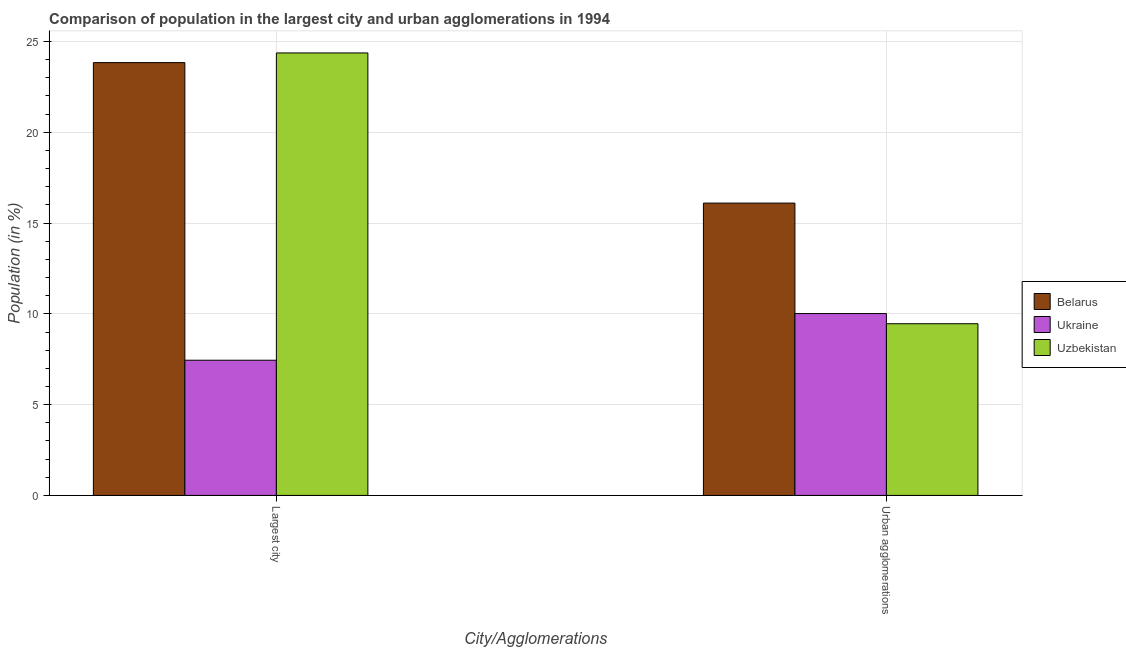How many different coloured bars are there?
Offer a very short reply. 3. Are the number of bars on each tick of the X-axis equal?
Your response must be concise. Yes. How many bars are there on the 2nd tick from the left?
Offer a terse response. 3. How many bars are there on the 1st tick from the right?
Your answer should be very brief. 3. What is the label of the 2nd group of bars from the left?
Make the answer very short. Urban agglomerations. What is the population in the largest city in Belarus?
Keep it short and to the point. 23.84. Across all countries, what is the maximum population in urban agglomerations?
Ensure brevity in your answer.  16.1. Across all countries, what is the minimum population in urban agglomerations?
Provide a short and direct response. 9.46. In which country was the population in the largest city maximum?
Ensure brevity in your answer.  Uzbekistan. In which country was the population in the largest city minimum?
Your answer should be very brief. Ukraine. What is the total population in the largest city in the graph?
Your answer should be compact. 55.65. What is the difference between the population in urban agglomerations in Ukraine and that in Uzbekistan?
Your answer should be very brief. 0.56. What is the difference between the population in the largest city in Belarus and the population in urban agglomerations in Uzbekistan?
Your answer should be compact. 14.38. What is the average population in the largest city per country?
Ensure brevity in your answer.  18.55. What is the difference between the population in the largest city and population in urban agglomerations in Belarus?
Your response must be concise. 7.74. In how many countries, is the population in the largest city greater than 2 %?
Your response must be concise. 3. What is the ratio of the population in the largest city in Ukraine to that in Uzbekistan?
Provide a succinct answer. 0.31. In how many countries, is the population in the largest city greater than the average population in the largest city taken over all countries?
Give a very brief answer. 2. What does the 2nd bar from the left in Urban agglomerations represents?
Provide a short and direct response. Ukraine. What does the 3rd bar from the right in Urban agglomerations represents?
Offer a terse response. Belarus. How many countries are there in the graph?
Your answer should be compact. 3. Are the values on the major ticks of Y-axis written in scientific E-notation?
Offer a terse response. No. Does the graph contain any zero values?
Make the answer very short. No. How many legend labels are there?
Offer a terse response. 3. What is the title of the graph?
Keep it short and to the point. Comparison of population in the largest city and urban agglomerations in 1994. Does "Monaco" appear as one of the legend labels in the graph?
Your answer should be very brief. No. What is the label or title of the X-axis?
Your response must be concise. City/Agglomerations. What is the label or title of the Y-axis?
Offer a terse response. Population (in %). What is the Population (in %) in Belarus in Largest city?
Ensure brevity in your answer.  23.84. What is the Population (in %) of Ukraine in Largest city?
Give a very brief answer. 7.45. What is the Population (in %) in Uzbekistan in Largest city?
Give a very brief answer. 24.37. What is the Population (in %) in Belarus in Urban agglomerations?
Offer a terse response. 16.1. What is the Population (in %) of Ukraine in Urban agglomerations?
Keep it short and to the point. 10.02. What is the Population (in %) in Uzbekistan in Urban agglomerations?
Your answer should be compact. 9.46. Across all City/Agglomerations, what is the maximum Population (in %) in Belarus?
Provide a short and direct response. 23.84. Across all City/Agglomerations, what is the maximum Population (in %) of Ukraine?
Offer a very short reply. 10.02. Across all City/Agglomerations, what is the maximum Population (in %) of Uzbekistan?
Make the answer very short. 24.37. Across all City/Agglomerations, what is the minimum Population (in %) of Belarus?
Provide a succinct answer. 16.1. Across all City/Agglomerations, what is the minimum Population (in %) of Ukraine?
Your answer should be compact. 7.45. Across all City/Agglomerations, what is the minimum Population (in %) of Uzbekistan?
Keep it short and to the point. 9.46. What is the total Population (in %) in Belarus in the graph?
Ensure brevity in your answer.  39.94. What is the total Population (in %) in Ukraine in the graph?
Your answer should be very brief. 17.46. What is the total Population (in %) in Uzbekistan in the graph?
Keep it short and to the point. 33.82. What is the difference between the Population (in %) in Belarus in Largest city and that in Urban agglomerations?
Keep it short and to the point. 7.74. What is the difference between the Population (in %) of Ukraine in Largest city and that in Urban agglomerations?
Keep it short and to the point. -2.57. What is the difference between the Population (in %) in Uzbekistan in Largest city and that in Urban agglomerations?
Offer a very short reply. 14.91. What is the difference between the Population (in %) of Belarus in Largest city and the Population (in %) of Ukraine in Urban agglomerations?
Give a very brief answer. 13.82. What is the difference between the Population (in %) of Belarus in Largest city and the Population (in %) of Uzbekistan in Urban agglomerations?
Keep it short and to the point. 14.38. What is the difference between the Population (in %) in Ukraine in Largest city and the Population (in %) in Uzbekistan in Urban agglomerations?
Provide a succinct answer. -2.01. What is the average Population (in %) in Belarus per City/Agglomerations?
Ensure brevity in your answer.  19.97. What is the average Population (in %) in Ukraine per City/Agglomerations?
Give a very brief answer. 8.73. What is the average Population (in %) in Uzbekistan per City/Agglomerations?
Provide a succinct answer. 16.91. What is the difference between the Population (in %) of Belarus and Population (in %) of Ukraine in Largest city?
Your response must be concise. 16.39. What is the difference between the Population (in %) of Belarus and Population (in %) of Uzbekistan in Largest city?
Provide a short and direct response. -0.53. What is the difference between the Population (in %) of Ukraine and Population (in %) of Uzbekistan in Largest city?
Give a very brief answer. -16.92. What is the difference between the Population (in %) of Belarus and Population (in %) of Ukraine in Urban agglomerations?
Provide a short and direct response. 6.08. What is the difference between the Population (in %) in Belarus and Population (in %) in Uzbekistan in Urban agglomerations?
Make the answer very short. 6.64. What is the difference between the Population (in %) in Ukraine and Population (in %) in Uzbekistan in Urban agglomerations?
Your response must be concise. 0.56. What is the ratio of the Population (in %) in Belarus in Largest city to that in Urban agglomerations?
Provide a succinct answer. 1.48. What is the ratio of the Population (in %) of Ukraine in Largest city to that in Urban agglomerations?
Provide a succinct answer. 0.74. What is the ratio of the Population (in %) of Uzbekistan in Largest city to that in Urban agglomerations?
Make the answer very short. 2.58. What is the difference between the highest and the second highest Population (in %) in Belarus?
Ensure brevity in your answer.  7.74. What is the difference between the highest and the second highest Population (in %) in Ukraine?
Your response must be concise. 2.57. What is the difference between the highest and the second highest Population (in %) of Uzbekistan?
Keep it short and to the point. 14.91. What is the difference between the highest and the lowest Population (in %) in Belarus?
Provide a short and direct response. 7.74. What is the difference between the highest and the lowest Population (in %) in Ukraine?
Offer a very short reply. 2.57. What is the difference between the highest and the lowest Population (in %) of Uzbekistan?
Your response must be concise. 14.91. 